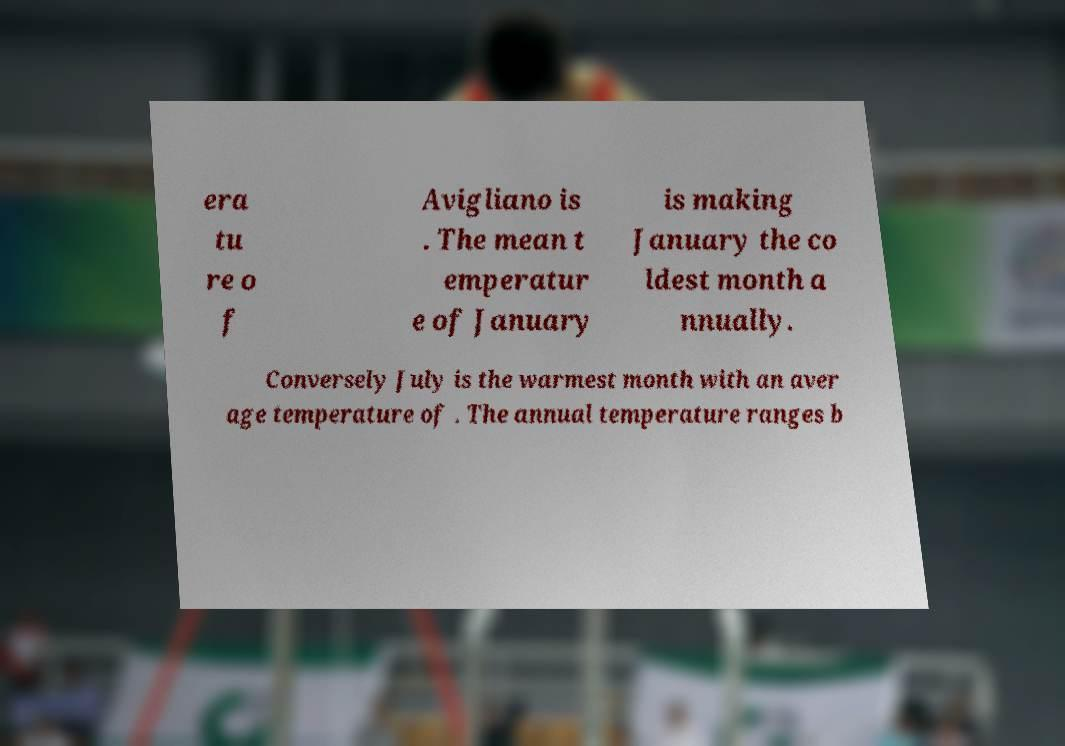What messages or text are displayed in this image? I need them in a readable, typed format. era tu re o f Avigliano is . The mean t emperatur e of January is making January the co ldest month a nnually. Conversely July is the warmest month with an aver age temperature of . The annual temperature ranges b 